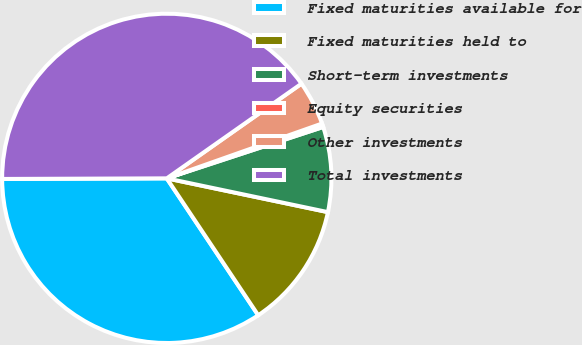Convert chart. <chart><loc_0><loc_0><loc_500><loc_500><pie_chart><fcel>Fixed maturities available for<fcel>Fixed maturities held to<fcel>Short-term investments<fcel>Equity securities<fcel>Other investments<fcel>Total investments<nl><fcel>34.32%<fcel>12.34%<fcel>8.34%<fcel>0.35%<fcel>4.35%<fcel>40.31%<nl></chart> 